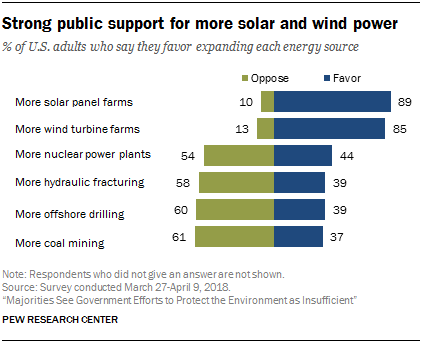Indicate a few pertinent items in this graphic. I oppose the construction of more solar panel farms with a score of 10, but favor them with a score of 89. According to the study, if 500 people were asked whether they support or oppose the installation of more solar panel farms, 50 would oppose and 445 would favor it. 